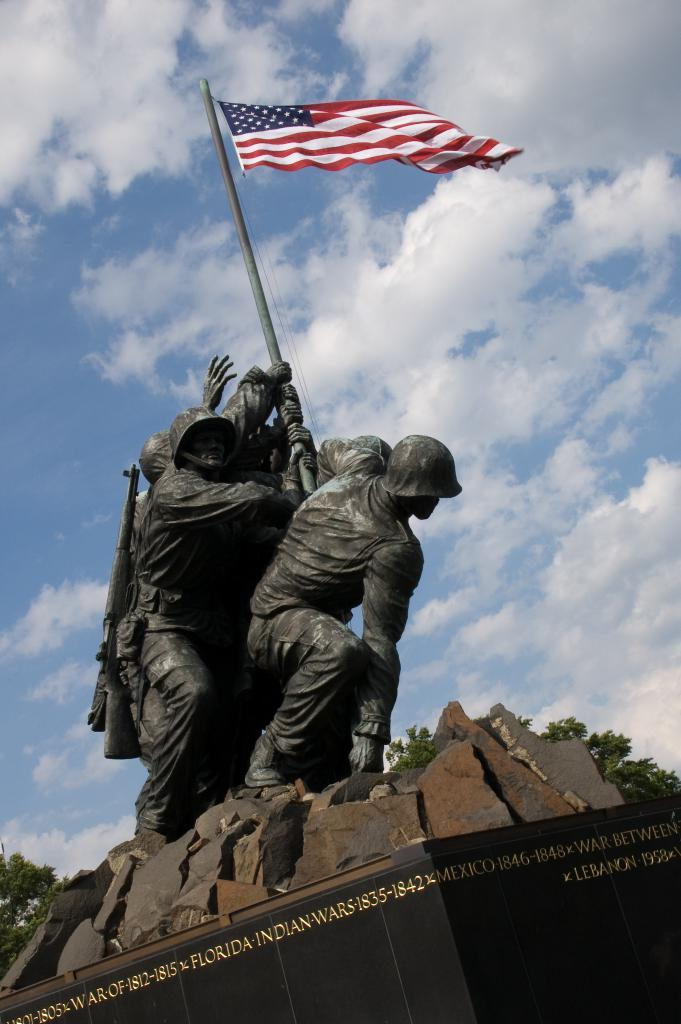What is the main subject in the image? There is a statue in the image. What else can be seen in the image besides the statue? There is a flag and writing on a stone in the image. What is visible in the background of the image? The sky and trees are visible in the background of the image. Where is the store located in the image? There is no store present in the image. Is there a bike visible in the image? There is no bike present in the image. 